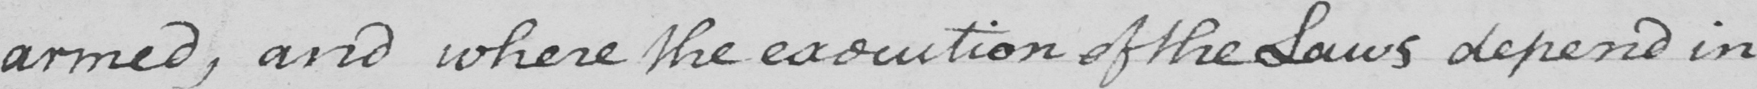What does this handwritten line say? armed , and where the execution of the Laws depend in 